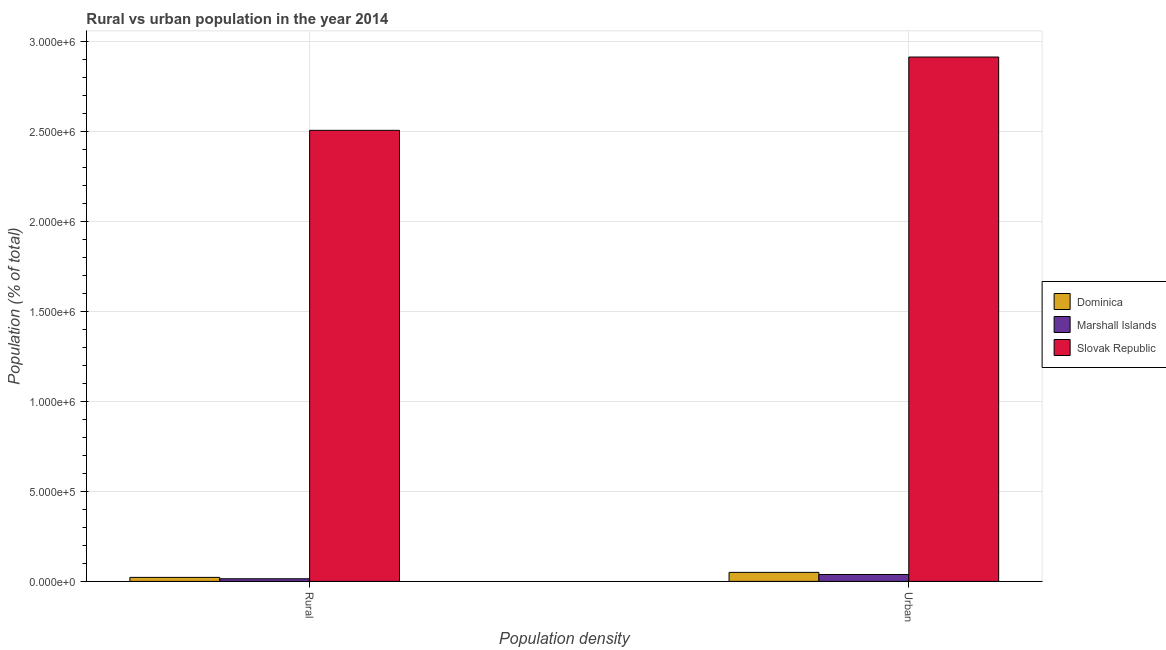Are the number of bars on each tick of the X-axis equal?
Provide a succinct answer. Yes. How many bars are there on the 1st tick from the right?
Provide a succinct answer. 3. What is the label of the 2nd group of bars from the left?
Your answer should be compact. Urban. What is the rural population density in Marshall Islands?
Offer a very short reply. 1.46e+04. Across all countries, what is the maximum urban population density?
Your response must be concise. 2.91e+06. Across all countries, what is the minimum urban population density?
Keep it short and to the point. 3.83e+04. In which country was the urban population density maximum?
Your response must be concise. Slovak Republic. In which country was the rural population density minimum?
Give a very brief answer. Marshall Islands. What is the total urban population density in the graph?
Offer a very short reply. 3.00e+06. What is the difference between the urban population density in Slovak Republic and that in Marshall Islands?
Ensure brevity in your answer.  2.87e+06. What is the difference between the urban population density in Dominica and the rural population density in Marshall Islands?
Provide a succinct answer. 3.55e+04. What is the average urban population density per country?
Your answer should be compact. 1.00e+06. What is the difference between the rural population density and urban population density in Slovak Republic?
Give a very brief answer. -4.07e+05. In how many countries, is the rural population density greater than 2200000 %?
Provide a short and direct response. 1. What is the ratio of the rural population density in Dominica to that in Marshall Islands?
Keep it short and to the point. 1.52. What does the 1st bar from the left in Urban represents?
Provide a short and direct response. Dominica. What does the 2nd bar from the right in Urban represents?
Your answer should be compact. Marshall Islands. How many bars are there?
Your answer should be very brief. 6. Are all the bars in the graph horizontal?
Make the answer very short. No. What is the difference between two consecutive major ticks on the Y-axis?
Give a very brief answer. 5.00e+05. Does the graph contain grids?
Give a very brief answer. Yes. How many legend labels are there?
Your response must be concise. 3. What is the title of the graph?
Keep it short and to the point. Rural vs urban population in the year 2014. What is the label or title of the X-axis?
Offer a terse response. Population density. What is the label or title of the Y-axis?
Your response must be concise. Population (% of total). What is the Population (% of total) in Dominica in Rural?
Your answer should be very brief. 2.22e+04. What is the Population (% of total) of Marshall Islands in Rural?
Your answer should be compact. 1.46e+04. What is the Population (% of total) of Slovak Republic in Rural?
Your answer should be very brief. 2.51e+06. What is the Population (% of total) of Dominica in Urban?
Offer a very short reply. 5.01e+04. What is the Population (% of total) in Marshall Islands in Urban?
Make the answer very short. 3.83e+04. What is the Population (% of total) in Slovak Republic in Urban?
Give a very brief answer. 2.91e+06. Across all Population density, what is the maximum Population (% of total) in Dominica?
Provide a succinct answer. 5.01e+04. Across all Population density, what is the maximum Population (% of total) of Marshall Islands?
Make the answer very short. 3.83e+04. Across all Population density, what is the maximum Population (% of total) of Slovak Republic?
Keep it short and to the point. 2.91e+06. Across all Population density, what is the minimum Population (% of total) of Dominica?
Provide a short and direct response. 2.22e+04. Across all Population density, what is the minimum Population (% of total) of Marshall Islands?
Provide a short and direct response. 1.46e+04. Across all Population density, what is the minimum Population (% of total) of Slovak Republic?
Make the answer very short. 2.51e+06. What is the total Population (% of total) of Dominica in the graph?
Keep it short and to the point. 7.23e+04. What is the total Population (% of total) of Marshall Islands in the graph?
Your answer should be compact. 5.29e+04. What is the total Population (% of total) in Slovak Republic in the graph?
Give a very brief answer. 5.42e+06. What is the difference between the Population (% of total) of Dominica in Rural and that in Urban?
Offer a very short reply. -2.79e+04. What is the difference between the Population (% of total) of Marshall Islands in Rural and that in Urban?
Keep it short and to the point. -2.37e+04. What is the difference between the Population (% of total) in Slovak Republic in Rural and that in Urban?
Your answer should be compact. -4.07e+05. What is the difference between the Population (% of total) of Dominica in Rural and the Population (% of total) of Marshall Islands in Urban?
Ensure brevity in your answer.  -1.61e+04. What is the difference between the Population (% of total) of Dominica in Rural and the Population (% of total) of Slovak Republic in Urban?
Ensure brevity in your answer.  -2.89e+06. What is the difference between the Population (% of total) in Marshall Islands in Rural and the Population (% of total) in Slovak Republic in Urban?
Ensure brevity in your answer.  -2.90e+06. What is the average Population (% of total) in Dominica per Population density?
Provide a succinct answer. 3.62e+04. What is the average Population (% of total) of Marshall Islands per Population density?
Provide a short and direct response. 2.64e+04. What is the average Population (% of total) in Slovak Republic per Population density?
Provide a succinct answer. 2.71e+06. What is the difference between the Population (% of total) of Dominica and Population (% of total) of Marshall Islands in Rural?
Your answer should be compact. 7654. What is the difference between the Population (% of total) in Dominica and Population (% of total) in Slovak Republic in Rural?
Keep it short and to the point. -2.48e+06. What is the difference between the Population (% of total) of Marshall Islands and Population (% of total) of Slovak Republic in Rural?
Offer a terse response. -2.49e+06. What is the difference between the Population (% of total) of Dominica and Population (% of total) of Marshall Islands in Urban?
Your response must be concise. 1.18e+04. What is the difference between the Population (% of total) in Dominica and Population (% of total) in Slovak Republic in Urban?
Keep it short and to the point. -2.86e+06. What is the difference between the Population (% of total) in Marshall Islands and Population (% of total) in Slovak Republic in Urban?
Give a very brief answer. -2.87e+06. What is the ratio of the Population (% of total) in Dominica in Rural to that in Urban?
Your response must be concise. 0.44. What is the ratio of the Population (% of total) in Marshall Islands in Rural to that in Urban?
Your answer should be very brief. 0.38. What is the ratio of the Population (% of total) in Slovak Republic in Rural to that in Urban?
Your answer should be compact. 0.86. What is the difference between the highest and the second highest Population (% of total) in Dominica?
Your response must be concise. 2.79e+04. What is the difference between the highest and the second highest Population (% of total) of Marshall Islands?
Your answer should be compact. 2.37e+04. What is the difference between the highest and the second highest Population (% of total) of Slovak Republic?
Your answer should be very brief. 4.07e+05. What is the difference between the highest and the lowest Population (% of total) of Dominica?
Provide a succinct answer. 2.79e+04. What is the difference between the highest and the lowest Population (% of total) of Marshall Islands?
Provide a short and direct response. 2.37e+04. What is the difference between the highest and the lowest Population (% of total) in Slovak Republic?
Offer a very short reply. 4.07e+05. 